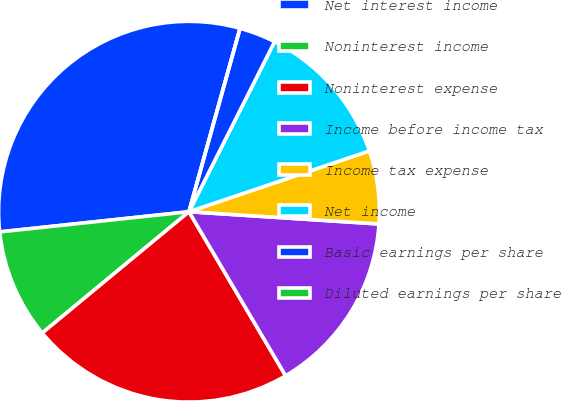<chart> <loc_0><loc_0><loc_500><loc_500><pie_chart><fcel>Net interest income<fcel>Noninterest income<fcel>Noninterest expense<fcel>Income before income tax<fcel>Income tax expense<fcel>Net income<fcel>Basic earnings per share<fcel>Diluted earnings per share<nl><fcel>31.01%<fcel>9.3%<fcel>22.48%<fcel>15.5%<fcel>6.2%<fcel>12.4%<fcel>3.1%<fcel>0.0%<nl></chart> 